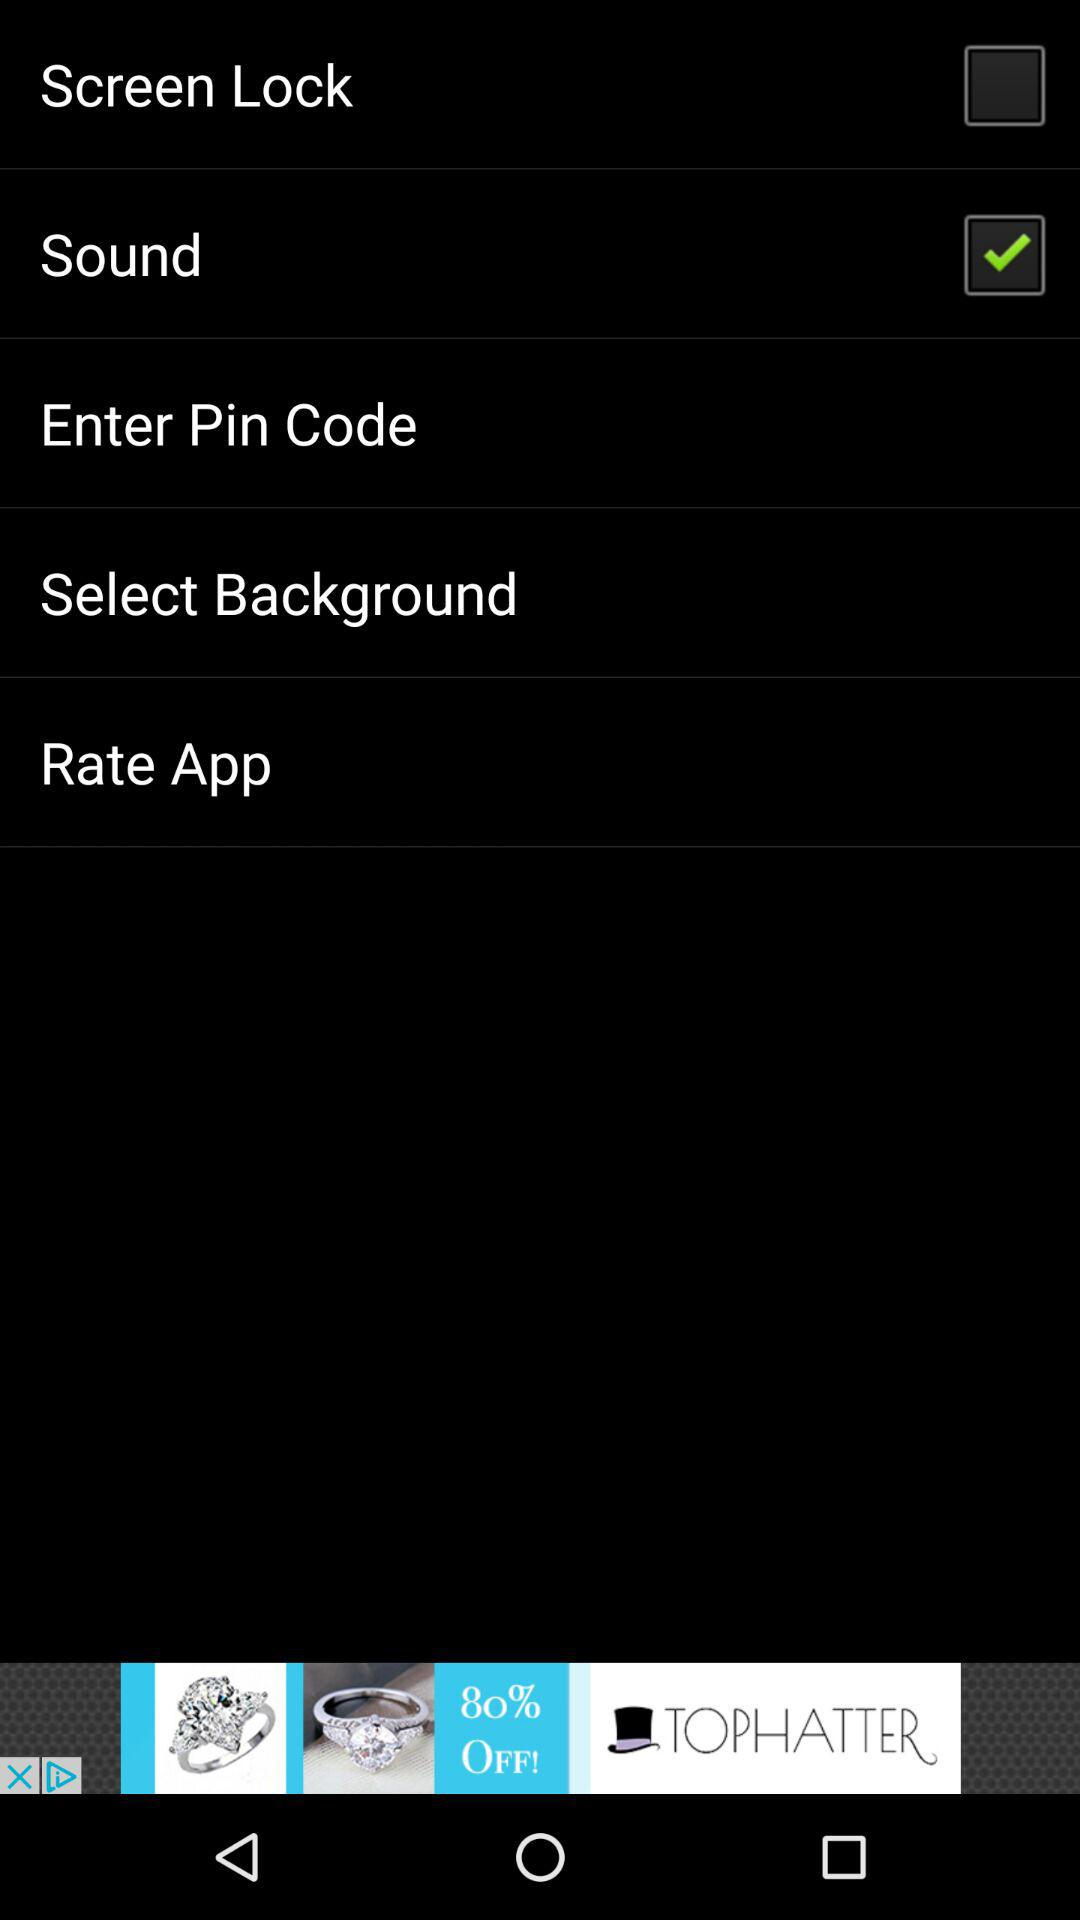What is the pin code?
When the provided information is insufficient, respond with <no answer>. <no answer> 